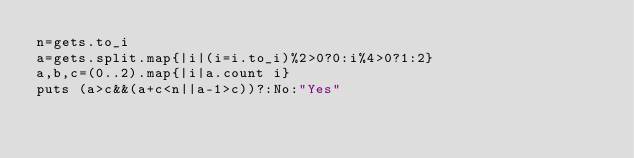<code> <loc_0><loc_0><loc_500><loc_500><_Ruby_>n=gets.to_i
a=gets.split.map{|i|(i=i.to_i)%2>0?0:i%4>0?1:2}
a,b,c=(0..2).map{|i|a.count i}
puts (a>c&&(a+c<n||a-1>c))?:No:"Yes"</code> 